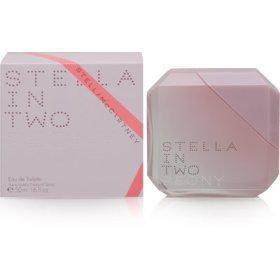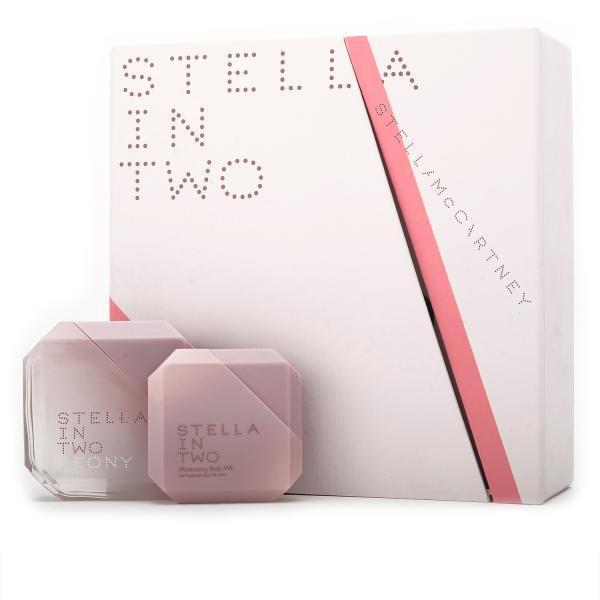The first image is the image on the left, the second image is the image on the right. Assess this claim about the two images: "One image contains a bottle shaped like an inverted triangle with its triangular cap alongside it, and the other image includes a bevel-edged square pink object.". Correct or not? Answer yes or no. No. The first image is the image on the left, the second image is the image on the right. For the images displayed, is the sentence "A perfume bottle is standing on one corner with the lid off." factually correct? Answer yes or no. No. 